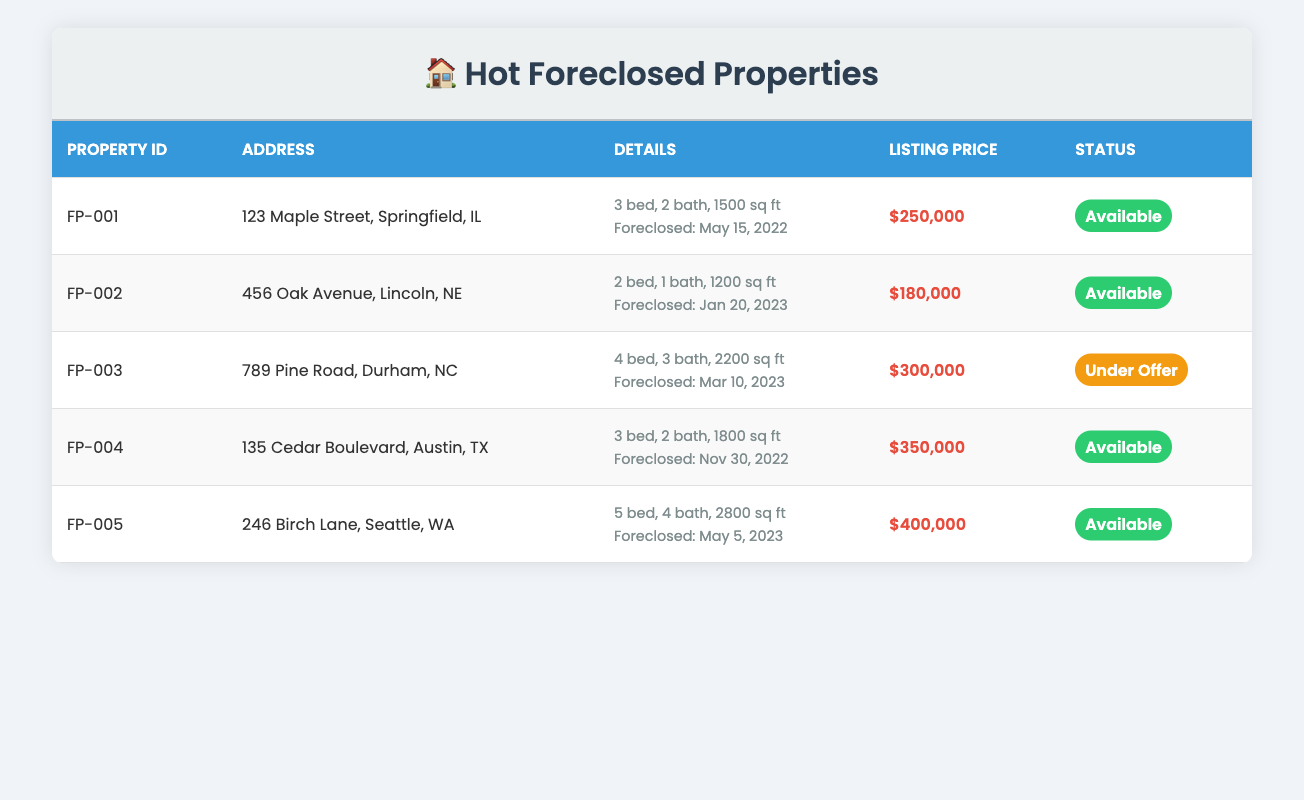What is the listing price of the property located at 456 Oak Avenue? The listing price for the property at 456 Oak Avenue, Lincoln, NE, is listed in the table under the Listing Price column. It shows $180,000.
Answer: $180,000 How many bedrooms does the property with ID FP-005 have? The number of bedrooms for the property with ID FP-005 is found in the Details column. It mentions that it has 5 bedrooms.
Answer: 5 Which property has the most square footage? To find the property with the most square footage, we check the square footage values: 1500, 1200, 2200, 1800, and 2800. The highest value is 2800, which belongs to property FP-005 located at 246 Birch Lane, Seattle, WA.
Answer: FP-005 Is the property located at 135 Cedar Boulevard currently available for sale? The status of the property at 135 Cedar Boulevard is checked in the Status column of the table. It shows "Available," indicating that it is indeed available for sale.
Answer: Yes What is the average listing price of the available properties? The available properties are FP-001, FP-002, FP-004, and FP-005. Their listing prices are $250,000, $180,000, $350,000, and $400,000. The total is $250,000 + $180,000 + $350,000 + $400,000 = $1,180,000. Dividing this by the 4 available properties gives an average of $1,180,000 / 4 = $295,000.
Answer: $295,000 How many properties in the table are currently under offer? By examining the Status column, we see that only one property, FP-003, is marked as "Under Offer." None of the other properties have that status.
Answer: 1 Which property has the least number of bathrooms, and what is that number? Looking at the Details column for bathrooms, the values are 2, 1, 3, 2, and 4. The lowest is 1, which corresponds to property FP-002 located at 456 Oak Avenue.
Answer: 1 What is the total number of bedrooms across all properties? To find the total number of bedrooms, we add the bedrooms from each property: 3 + 2 + 4 + 3 + 5 = 17. Therefore, the total number of bedrooms is 17.
Answer: 17 Is the listing price of property FP-003 higher than $300,000? Checking the Listing Price for property FP-003 in the table indicates it is listed at $300,000, so it is not higher than that amount.
Answer: No 